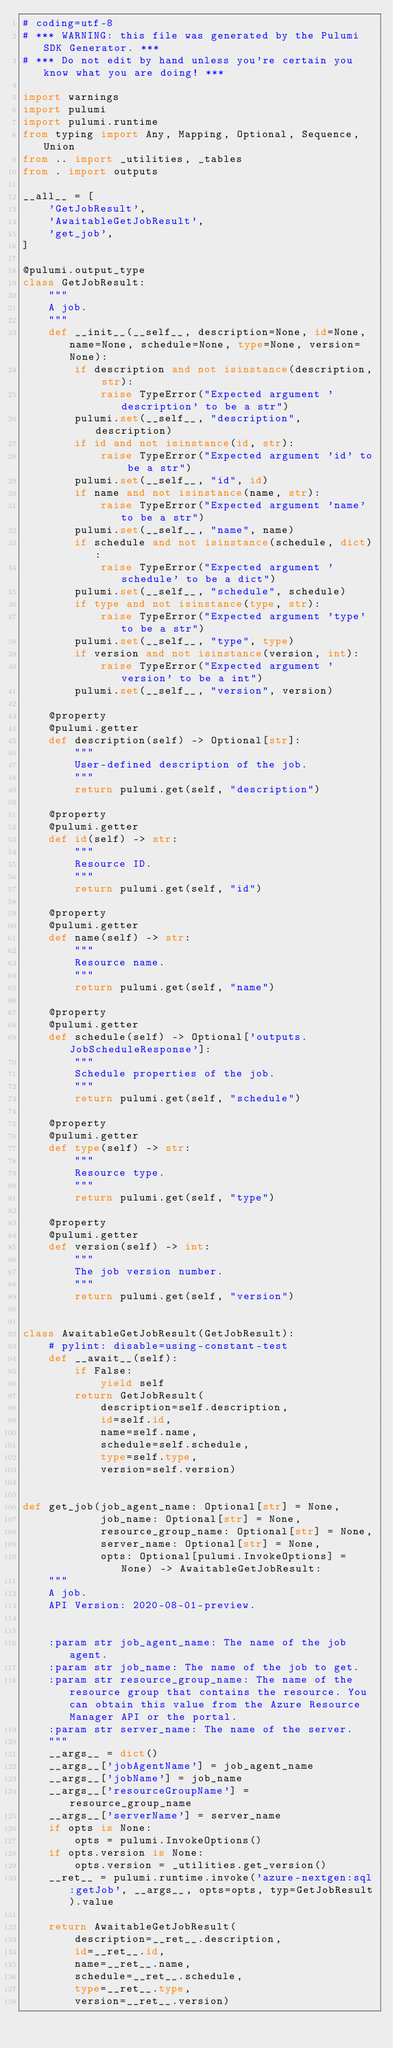<code> <loc_0><loc_0><loc_500><loc_500><_Python_># coding=utf-8
# *** WARNING: this file was generated by the Pulumi SDK Generator. ***
# *** Do not edit by hand unless you're certain you know what you are doing! ***

import warnings
import pulumi
import pulumi.runtime
from typing import Any, Mapping, Optional, Sequence, Union
from .. import _utilities, _tables
from . import outputs

__all__ = [
    'GetJobResult',
    'AwaitableGetJobResult',
    'get_job',
]

@pulumi.output_type
class GetJobResult:
    """
    A job.
    """
    def __init__(__self__, description=None, id=None, name=None, schedule=None, type=None, version=None):
        if description and not isinstance(description, str):
            raise TypeError("Expected argument 'description' to be a str")
        pulumi.set(__self__, "description", description)
        if id and not isinstance(id, str):
            raise TypeError("Expected argument 'id' to be a str")
        pulumi.set(__self__, "id", id)
        if name and not isinstance(name, str):
            raise TypeError("Expected argument 'name' to be a str")
        pulumi.set(__self__, "name", name)
        if schedule and not isinstance(schedule, dict):
            raise TypeError("Expected argument 'schedule' to be a dict")
        pulumi.set(__self__, "schedule", schedule)
        if type and not isinstance(type, str):
            raise TypeError("Expected argument 'type' to be a str")
        pulumi.set(__self__, "type", type)
        if version and not isinstance(version, int):
            raise TypeError("Expected argument 'version' to be a int")
        pulumi.set(__self__, "version", version)

    @property
    @pulumi.getter
    def description(self) -> Optional[str]:
        """
        User-defined description of the job.
        """
        return pulumi.get(self, "description")

    @property
    @pulumi.getter
    def id(self) -> str:
        """
        Resource ID.
        """
        return pulumi.get(self, "id")

    @property
    @pulumi.getter
    def name(self) -> str:
        """
        Resource name.
        """
        return pulumi.get(self, "name")

    @property
    @pulumi.getter
    def schedule(self) -> Optional['outputs.JobScheduleResponse']:
        """
        Schedule properties of the job.
        """
        return pulumi.get(self, "schedule")

    @property
    @pulumi.getter
    def type(self) -> str:
        """
        Resource type.
        """
        return pulumi.get(self, "type")

    @property
    @pulumi.getter
    def version(self) -> int:
        """
        The job version number.
        """
        return pulumi.get(self, "version")


class AwaitableGetJobResult(GetJobResult):
    # pylint: disable=using-constant-test
    def __await__(self):
        if False:
            yield self
        return GetJobResult(
            description=self.description,
            id=self.id,
            name=self.name,
            schedule=self.schedule,
            type=self.type,
            version=self.version)


def get_job(job_agent_name: Optional[str] = None,
            job_name: Optional[str] = None,
            resource_group_name: Optional[str] = None,
            server_name: Optional[str] = None,
            opts: Optional[pulumi.InvokeOptions] = None) -> AwaitableGetJobResult:
    """
    A job.
    API Version: 2020-08-01-preview.


    :param str job_agent_name: The name of the job agent.
    :param str job_name: The name of the job to get.
    :param str resource_group_name: The name of the resource group that contains the resource. You can obtain this value from the Azure Resource Manager API or the portal.
    :param str server_name: The name of the server.
    """
    __args__ = dict()
    __args__['jobAgentName'] = job_agent_name
    __args__['jobName'] = job_name
    __args__['resourceGroupName'] = resource_group_name
    __args__['serverName'] = server_name
    if opts is None:
        opts = pulumi.InvokeOptions()
    if opts.version is None:
        opts.version = _utilities.get_version()
    __ret__ = pulumi.runtime.invoke('azure-nextgen:sql:getJob', __args__, opts=opts, typ=GetJobResult).value

    return AwaitableGetJobResult(
        description=__ret__.description,
        id=__ret__.id,
        name=__ret__.name,
        schedule=__ret__.schedule,
        type=__ret__.type,
        version=__ret__.version)
</code> 